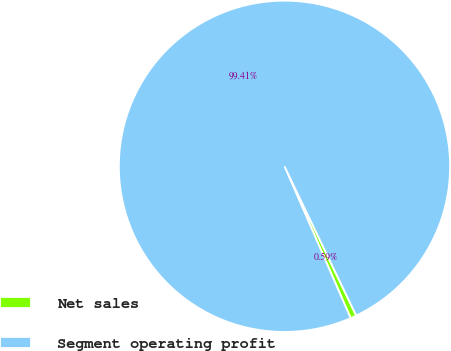Convert chart. <chart><loc_0><loc_0><loc_500><loc_500><pie_chart><fcel>Net sales<fcel>Segment operating profit<nl><fcel>0.59%<fcel>99.41%<nl></chart> 